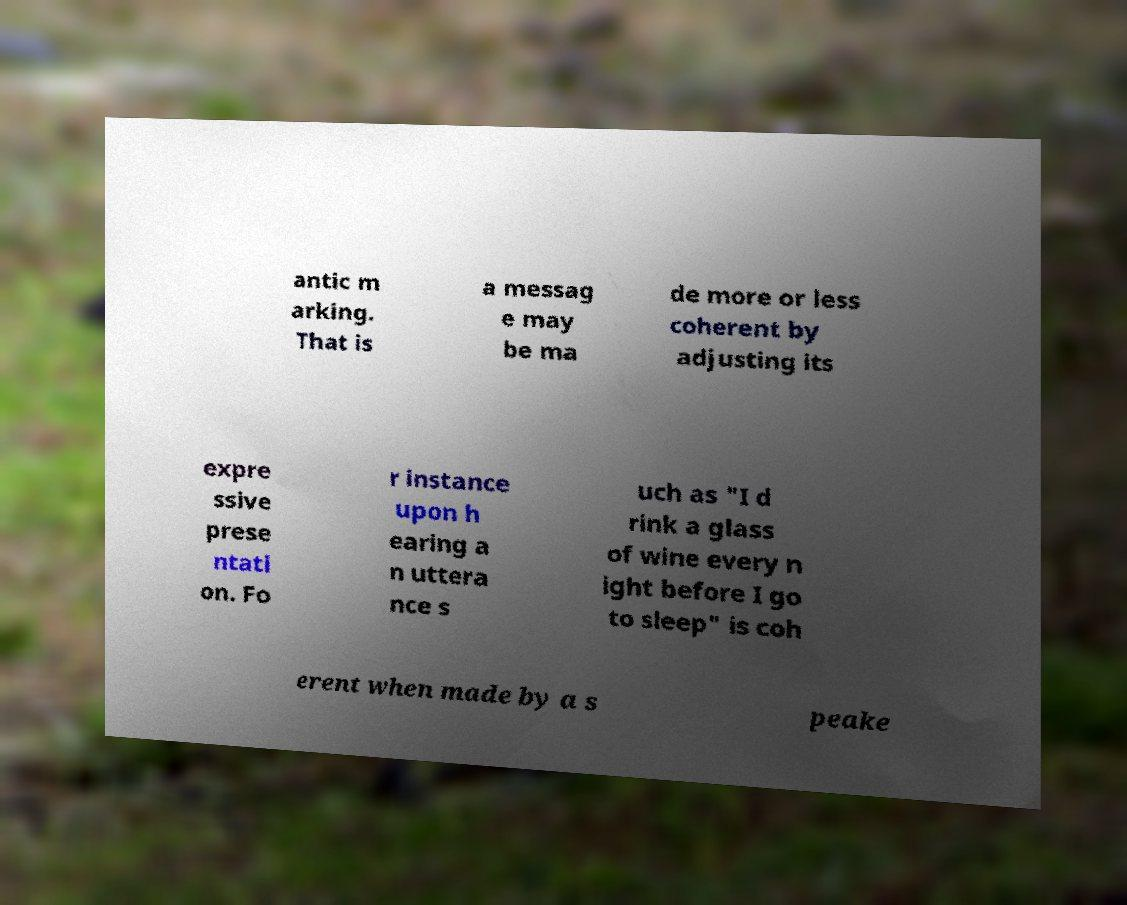Please identify and transcribe the text found in this image. antic m arking. That is a messag e may be ma de more or less coherent by adjusting its expre ssive prese ntati on. Fo r instance upon h earing a n uttera nce s uch as "I d rink a glass of wine every n ight before I go to sleep" is coh erent when made by a s peake 